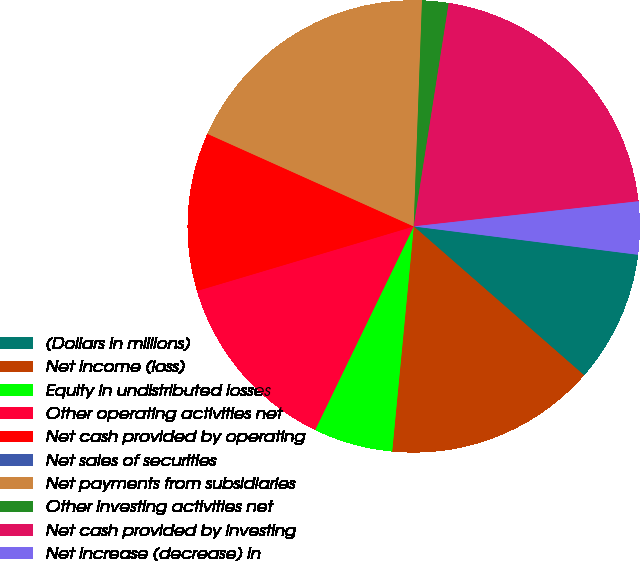Convert chart. <chart><loc_0><loc_0><loc_500><loc_500><pie_chart><fcel>(Dollars in millions)<fcel>Net income (loss)<fcel>Equity in undistributed losses<fcel>Other operating activities net<fcel>Net cash provided by operating<fcel>Net sales of securities<fcel>Net payments from subsidiaries<fcel>Other investing activities net<fcel>Net cash provided by investing<fcel>Net increase (decrease) in<nl><fcel>9.43%<fcel>15.09%<fcel>5.66%<fcel>13.21%<fcel>11.32%<fcel>0.0%<fcel>18.87%<fcel>1.89%<fcel>20.75%<fcel>3.77%<nl></chart> 